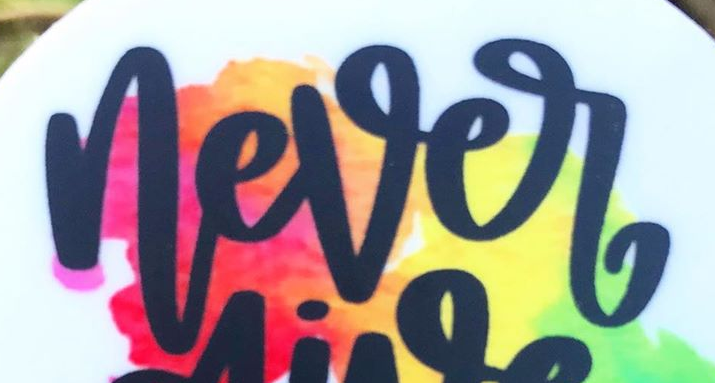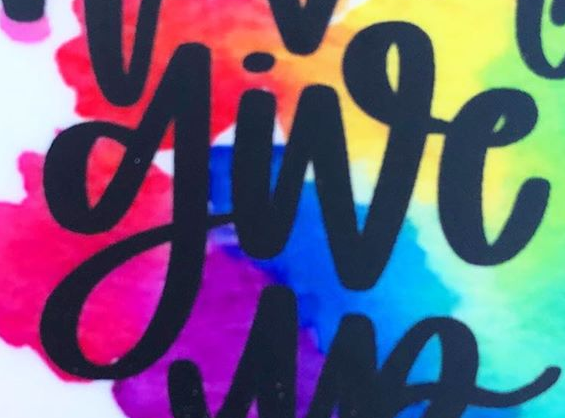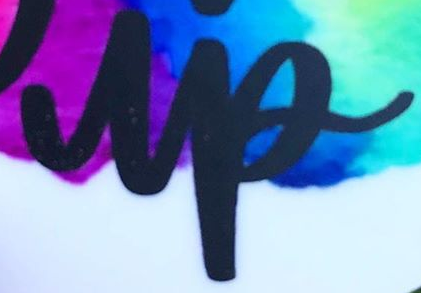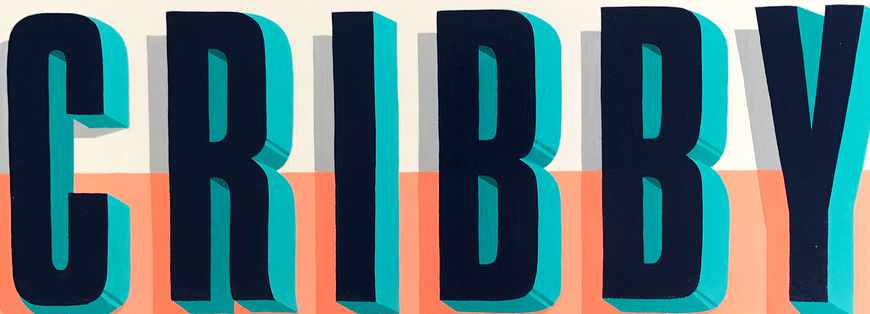Transcribe the words shown in these images in order, separated by a semicolon. never; give; up; CRIBBY 